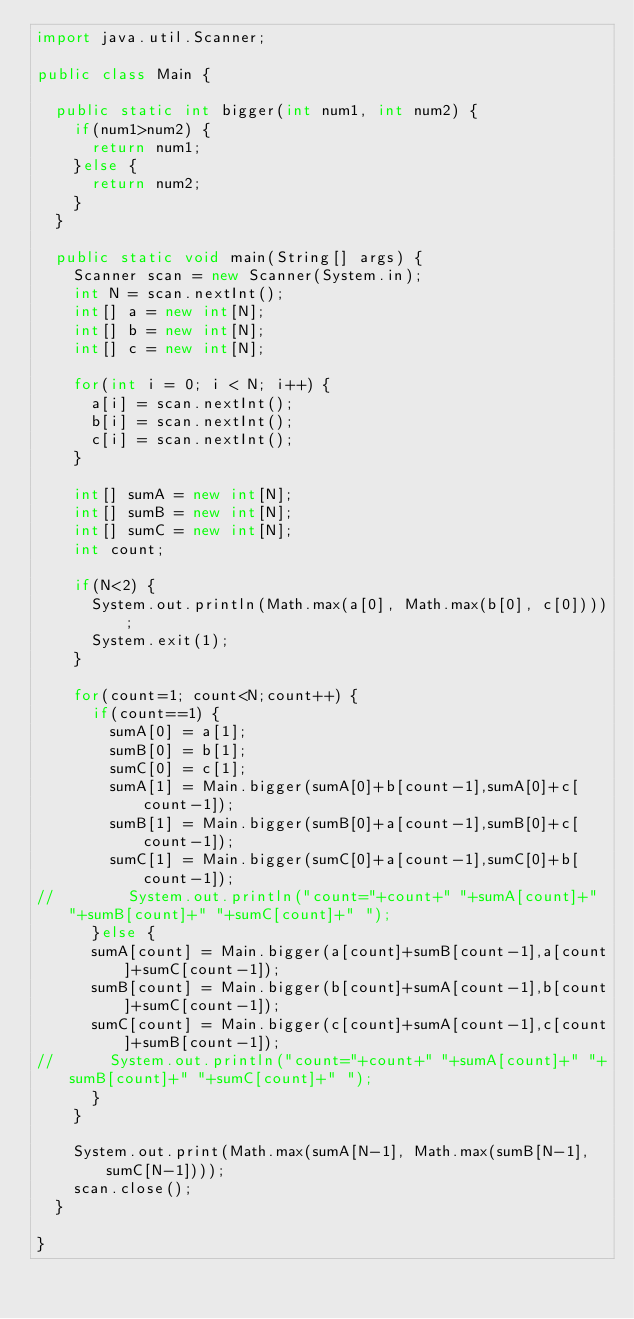Convert code to text. <code><loc_0><loc_0><loc_500><loc_500><_Java_>import java.util.Scanner;

public class Main {

	public static int bigger(int num1, int num2) {
		if(num1>num2) {
			return num1;
		}else {
			return num2;
		}
	}

	public static void main(String[] args) {
		Scanner scan = new Scanner(System.in);
		int N = scan.nextInt();
		int[] a = new int[N];
		int[] b = new int[N];
		int[] c = new int[N];

		for(int i = 0; i < N; i++) {
			a[i] = scan.nextInt();
			b[i] = scan.nextInt();
			c[i] = scan.nextInt();
		}

		int[] sumA = new int[N];
		int[] sumB = new int[N];
		int[] sumC = new int[N];
		int count;

		if(N<2) {
			System.out.println(Math.max(a[0], Math.max(b[0], c[0])));
			System.exit(1);
		}

		for(count=1; count<N;count++) {
			if(count==1) {
				sumA[0] = a[1];
				sumB[0] = b[1];
				sumC[0] = c[1];
				sumA[1] = Main.bigger(sumA[0]+b[count-1],sumA[0]+c[count-1]);
				sumB[1] = Main.bigger(sumB[0]+a[count-1],sumB[0]+c[count-1]);
				sumC[1] = Main.bigger(sumC[0]+a[count-1],sumC[0]+b[count-1]);
//				System.out.println("count="+count+" "+sumA[count]+" "+sumB[count]+" "+sumC[count]+" ");
			}else {
			sumA[count] = Main.bigger(a[count]+sumB[count-1],a[count]+sumC[count-1]);
			sumB[count] = Main.bigger(b[count]+sumA[count-1],b[count]+sumC[count-1]);
			sumC[count] = Main.bigger(c[count]+sumA[count-1],c[count]+sumB[count-1]);
//			System.out.println("count="+count+" "+sumA[count]+" "+sumB[count]+" "+sumC[count]+" ");
			}
		}

		System.out.print(Math.max(sumA[N-1], Math.max(sumB[N-1], sumC[N-1])));
		scan.close();
	}

}
</code> 